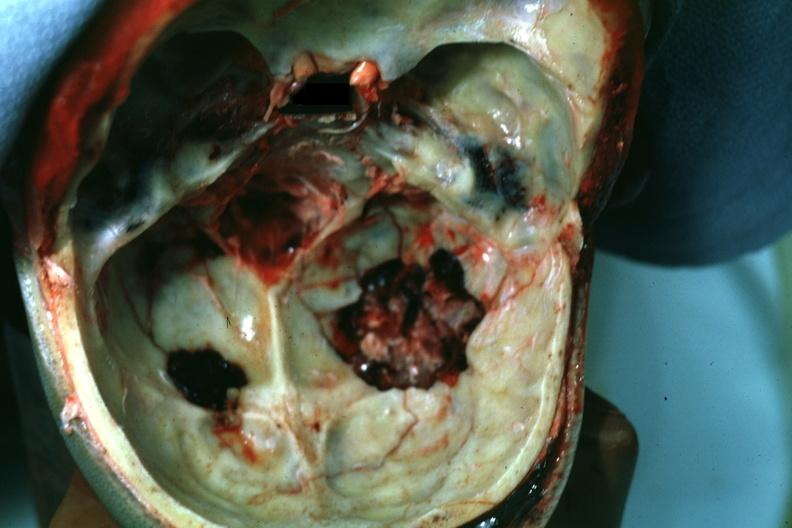what is present?
Answer the question using a single word or phrase. Bone, calvarium 